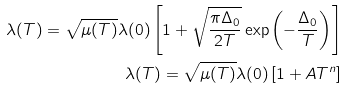Convert formula to latex. <formula><loc_0><loc_0><loc_500><loc_500>\lambda ( T ) = \sqrt { \mu ( T ) } \lambda ( 0 ) \left [ 1 + \sqrt { \frac { \pi \Delta _ { 0 } } { 2 T } } \exp \left ( - \frac { \Delta _ { 0 } } { T } \right ) \right ] \\ \lambda ( T ) = \sqrt { \mu ( T ) } \lambda ( 0 ) \left [ 1 + A T ^ { n } \right ]</formula> 